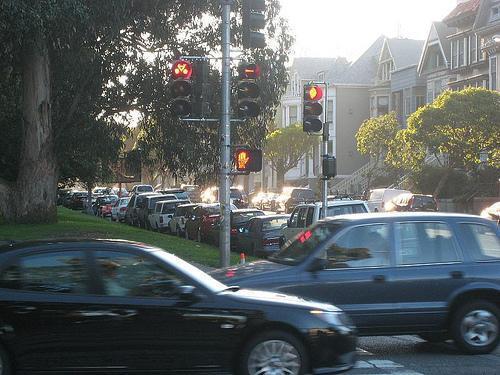How many white cars are in the photo?
Give a very brief answer. 5. How many red hand shaped lights are in the photo?
Give a very brief answer. 1. How many cars are there?
Give a very brief answer. 2. How many people are wearing a white shirt?
Give a very brief answer. 0. 